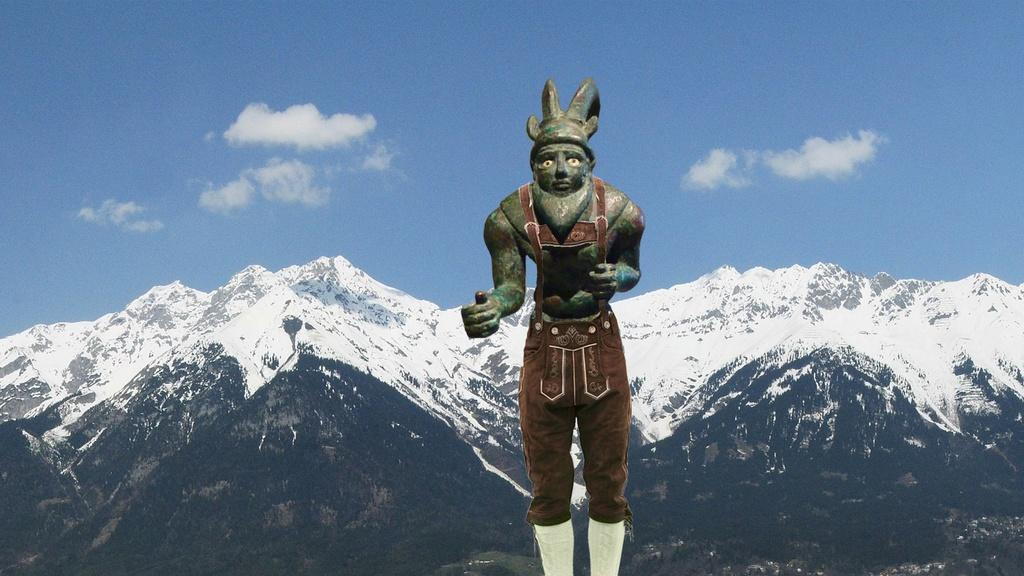What is the main subject of the image? There is a sculpture of a person in the image. What type of natural landscape can be seen in the image? Mountains are visible in the image. What else is visible in the image besides the sculpture and mountains? The sky is visible in the image. What type of cushion is being used by the person in the sculpture? There is no cushion present in the image, as it is a sculpture of a person and not an actual person. 